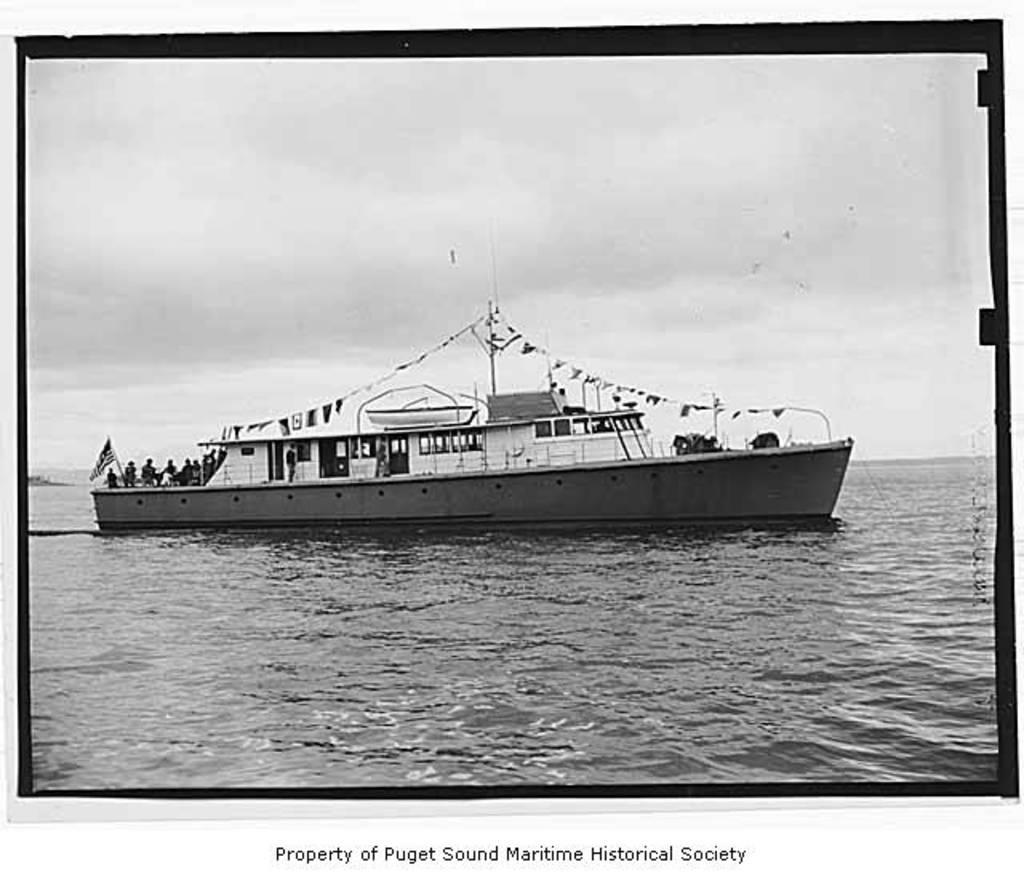<image>
Offer a succinct explanation of the picture presented. Postcard of a ship with the words "Property of Puget sound maritime historical society" on the bottom. 